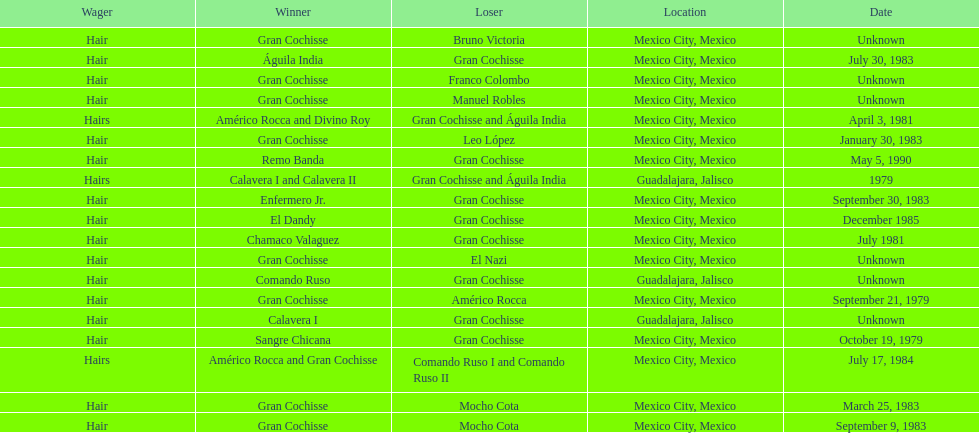How many games more than chamaco valaguez did sangre chicana win? 0. 